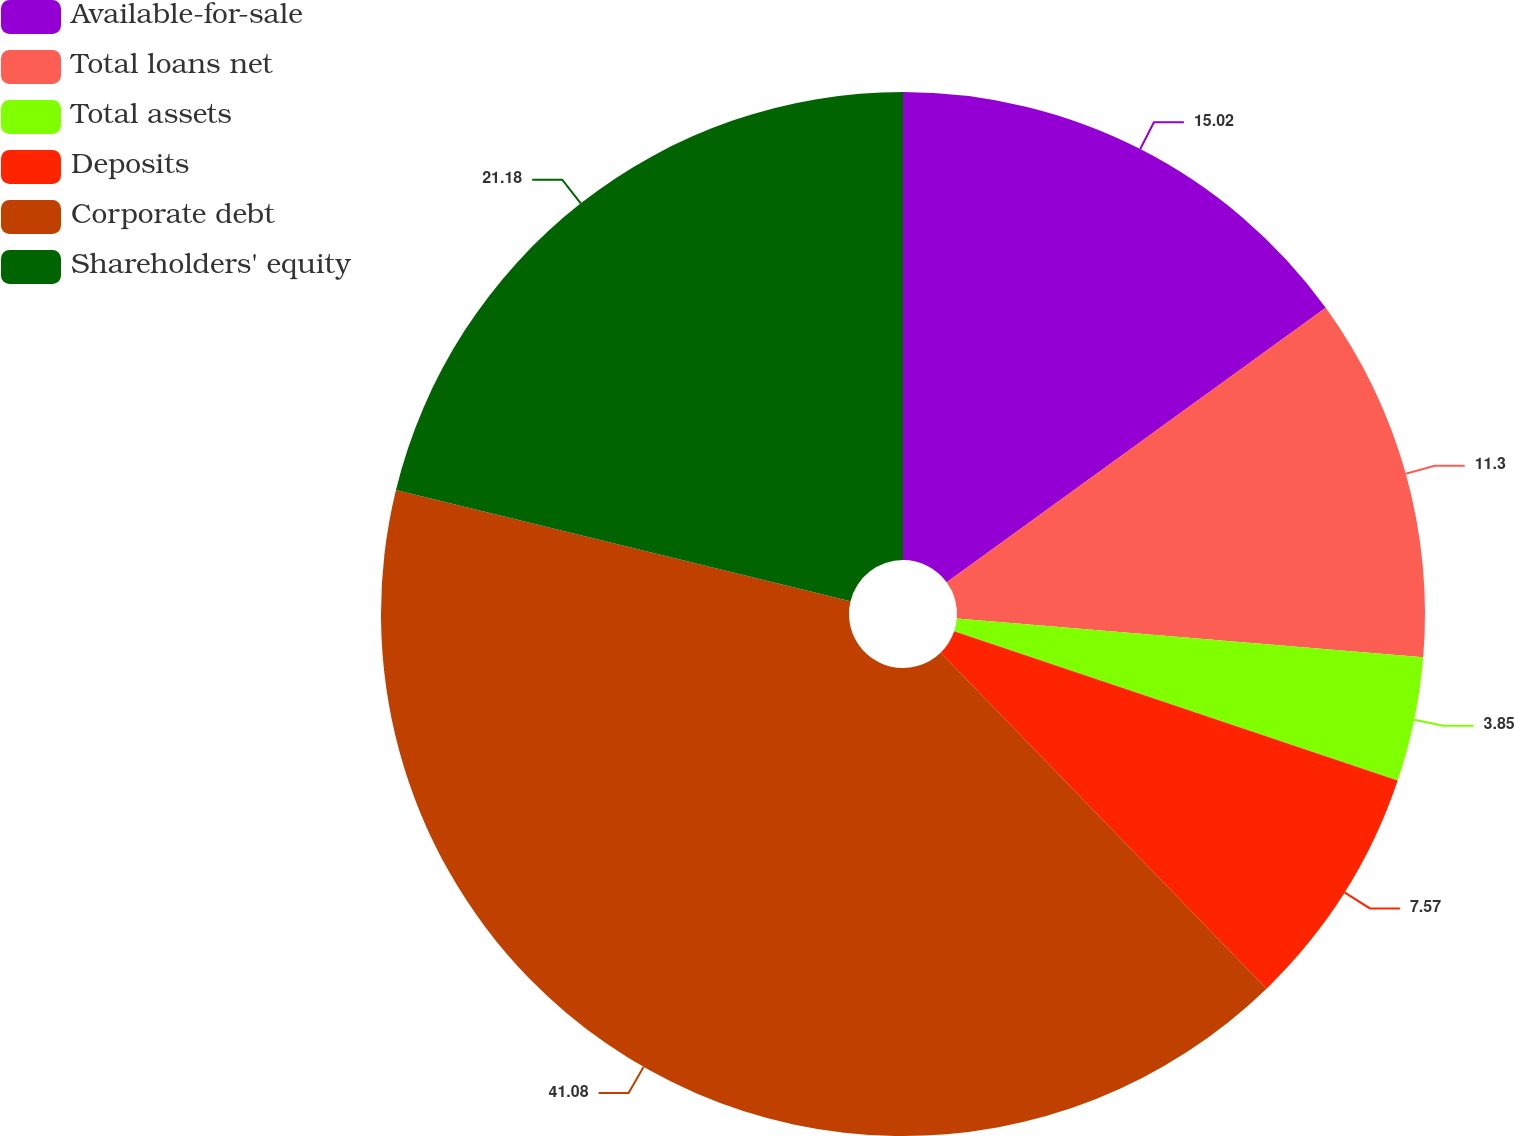Convert chart to OTSL. <chart><loc_0><loc_0><loc_500><loc_500><pie_chart><fcel>Available-for-sale<fcel>Total loans net<fcel>Total assets<fcel>Deposits<fcel>Corporate debt<fcel>Shareholders' equity<nl><fcel>15.02%<fcel>11.3%<fcel>3.85%<fcel>7.57%<fcel>41.08%<fcel>21.18%<nl></chart> 